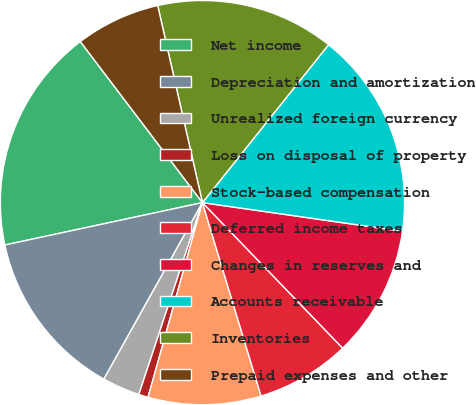Convert chart to OTSL. <chart><loc_0><loc_0><loc_500><loc_500><pie_chart><fcel>Net income<fcel>Depreciation and amortization<fcel>Unrealized foreign currency<fcel>Loss on disposal of property<fcel>Stock-based compensation<fcel>Deferred income taxes<fcel>Changes in reserves and<fcel>Accounts receivable<fcel>Inventories<fcel>Prepaid expenses and other<nl><fcel>18.04%<fcel>13.53%<fcel>3.01%<fcel>0.76%<fcel>9.02%<fcel>7.52%<fcel>10.53%<fcel>16.54%<fcel>14.28%<fcel>6.77%<nl></chart> 